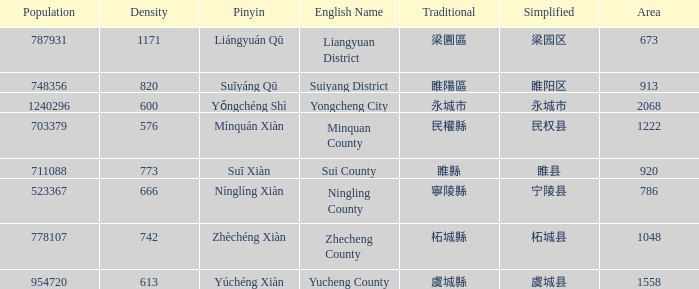What is the traditional form for 永城市? 永城市. 